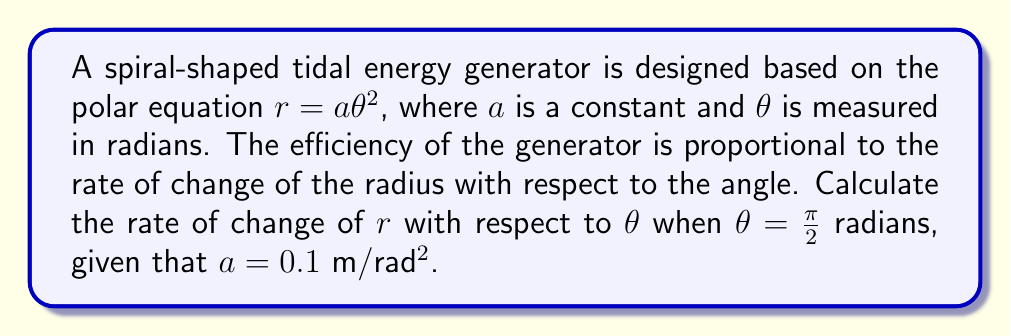Can you answer this question? To solve this problem, we need to find the derivative of $r$ with respect to $\theta$ and then evaluate it at $\theta = \frac{\pi}{2}$.

1) The given polar equation is:
   $$r = a\theta^2$$

2) To find the rate of change of $r$ with respect to $\theta$, we need to differentiate $r$ with respect to $\theta$:
   $$\frac{dr}{d\theta} = \frac{d}{d\theta}(a\theta^2)$$

3) Using the power rule of differentiation:
   $$\frac{dr}{d\theta} = 2a\theta$$

4) Now, we need to evaluate this at $\theta = \frac{\pi}{2}$ and $a = 0.1$ m/rad²:
   $$\left.\frac{dr}{d\theta}\right|_{\theta = \frac{\pi}{2}} = 2(0.1)\left(\frac{\pi}{2}\right)$$

5) Simplifying:
   $$\left.\frac{dr}{d\theta}\right|_{\theta = \frac{\pi}{2}} = 0.1\pi$$

This result represents the instantaneous rate of change of the radius with respect to the angle at $\theta = \frac{\pi}{2}$ radians, which is proportional to the generator's efficiency at this point.
Answer: $0.1\pi$ m/rad 